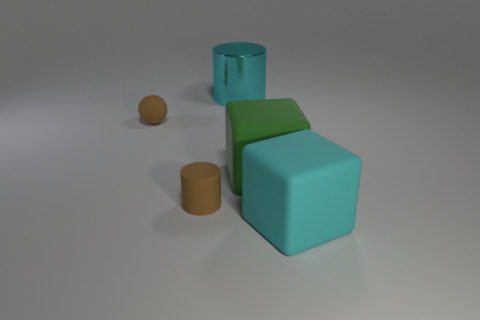There is a sphere that is the same color as the small cylinder; what is its size?
Offer a very short reply. Small. What color is the metallic object?
Your answer should be very brief. Cyan. There is a matte object that is behind the rubber cylinder and on the left side of the cyan cylinder; what color is it?
Provide a short and direct response. Brown. The big matte object on the right side of the big matte object that is behind the rubber cylinder that is on the left side of the big green matte object is what color?
Make the answer very short. Cyan. The cylinder that is the same size as the brown ball is what color?
Your answer should be very brief. Brown. What shape is the big object in front of the brown object in front of the tiny brown matte object behind the matte cylinder?
Offer a very short reply. Cube. There is a thing that is the same color as the matte cylinder; what shape is it?
Give a very brief answer. Sphere. What number of objects are either cyan metal cylinders or tiny brown cylinders in front of the large green rubber thing?
Ensure brevity in your answer.  2. Do the cyan object that is on the right side of the metallic cylinder and the big cyan cylinder have the same size?
Your response must be concise. Yes. There is a large cube that is right of the large green object; what is its material?
Give a very brief answer. Rubber. 